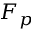Convert formula to latex. <formula><loc_0><loc_0><loc_500><loc_500>F _ { p }</formula> 